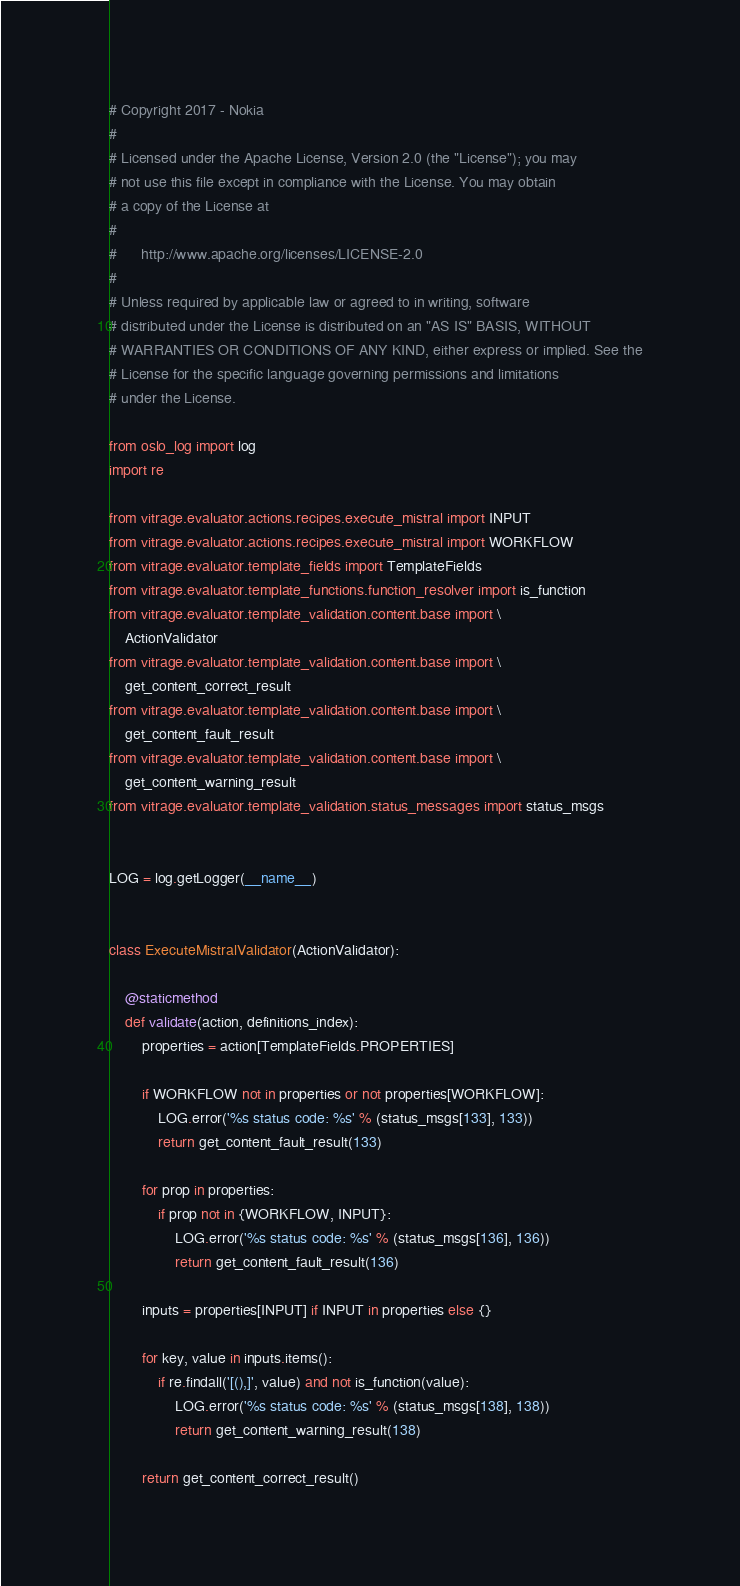<code> <loc_0><loc_0><loc_500><loc_500><_Python_># Copyright 2017 - Nokia
#
# Licensed under the Apache License, Version 2.0 (the "License"); you may
# not use this file except in compliance with the License. You may obtain
# a copy of the License at
#
#      http://www.apache.org/licenses/LICENSE-2.0
#
# Unless required by applicable law or agreed to in writing, software
# distributed under the License is distributed on an "AS IS" BASIS, WITHOUT
# WARRANTIES OR CONDITIONS OF ANY KIND, either express or implied. See the
# License for the specific language governing permissions and limitations
# under the License.

from oslo_log import log
import re

from vitrage.evaluator.actions.recipes.execute_mistral import INPUT
from vitrage.evaluator.actions.recipes.execute_mistral import WORKFLOW
from vitrage.evaluator.template_fields import TemplateFields
from vitrage.evaluator.template_functions.function_resolver import is_function
from vitrage.evaluator.template_validation.content.base import \
    ActionValidator
from vitrage.evaluator.template_validation.content.base import \
    get_content_correct_result
from vitrage.evaluator.template_validation.content.base import \
    get_content_fault_result
from vitrage.evaluator.template_validation.content.base import \
    get_content_warning_result
from vitrage.evaluator.template_validation.status_messages import status_msgs


LOG = log.getLogger(__name__)


class ExecuteMistralValidator(ActionValidator):

    @staticmethod
    def validate(action, definitions_index):
        properties = action[TemplateFields.PROPERTIES]

        if WORKFLOW not in properties or not properties[WORKFLOW]:
            LOG.error('%s status code: %s' % (status_msgs[133], 133))
            return get_content_fault_result(133)

        for prop in properties:
            if prop not in {WORKFLOW, INPUT}:
                LOG.error('%s status code: %s' % (status_msgs[136], 136))
                return get_content_fault_result(136)

        inputs = properties[INPUT] if INPUT in properties else {}

        for key, value in inputs.items():
            if re.findall('[(),]', value) and not is_function(value):
                LOG.error('%s status code: %s' % (status_msgs[138], 138))
                return get_content_warning_result(138)

        return get_content_correct_result()
</code> 